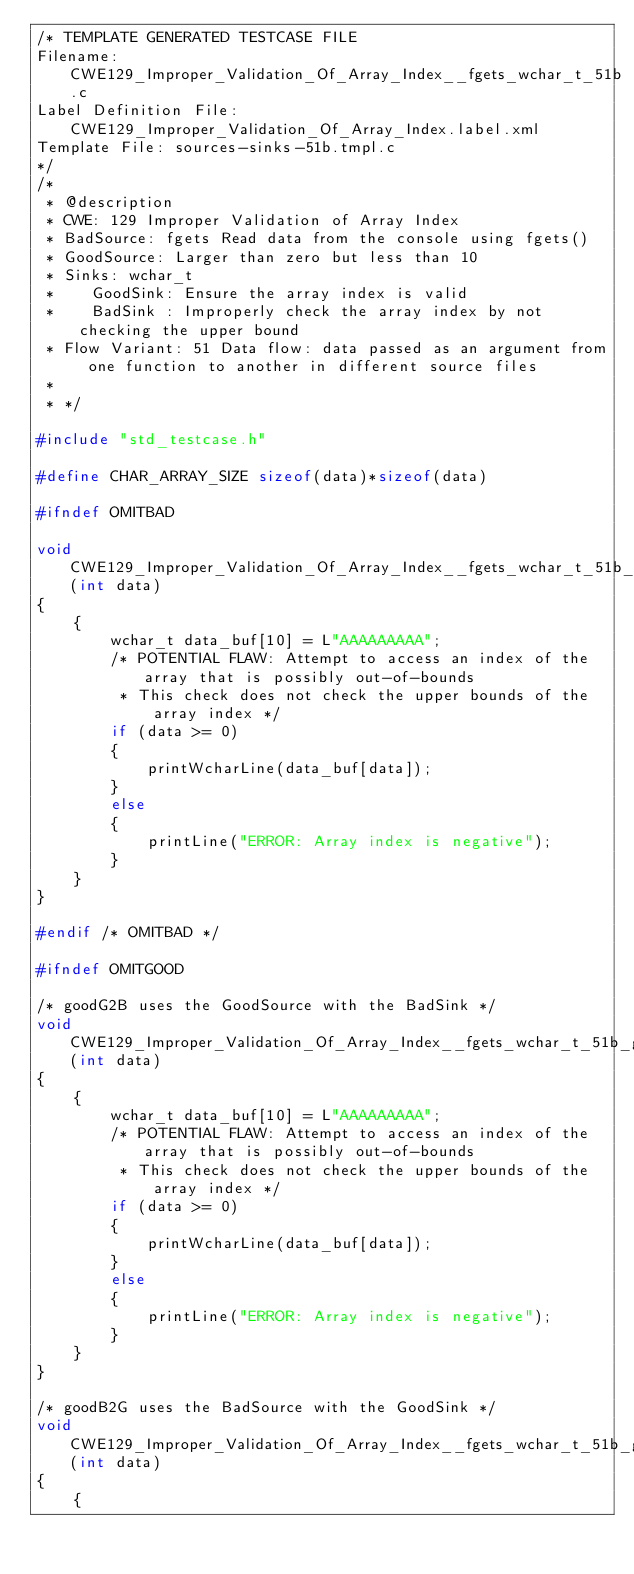Convert code to text. <code><loc_0><loc_0><loc_500><loc_500><_C_>/* TEMPLATE GENERATED TESTCASE FILE
Filename: CWE129_Improper_Validation_Of_Array_Index__fgets_wchar_t_51b.c
Label Definition File: CWE129_Improper_Validation_Of_Array_Index.label.xml
Template File: sources-sinks-51b.tmpl.c
*/
/*
 * @description
 * CWE: 129 Improper Validation of Array Index
 * BadSource: fgets Read data from the console using fgets()
 * GoodSource: Larger than zero but less than 10
 * Sinks: wchar_t
 *    GoodSink: Ensure the array index is valid
 *    BadSink : Improperly check the array index by not checking the upper bound
 * Flow Variant: 51 Data flow: data passed as an argument from one function to another in different source files
 *
 * */

#include "std_testcase.h"

#define CHAR_ARRAY_SIZE sizeof(data)*sizeof(data)

#ifndef OMITBAD

void CWE129_Improper_Validation_Of_Array_Index__fgets_wchar_t_51b_bad_sink(int data)
{
    {
        wchar_t data_buf[10] = L"AAAAAAAAA";
        /* POTENTIAL FLAW: Attempt to access an index of the array that is possibly out-of-bounds
         * This check does not check the upper bounds of the array index */
        if (data >= 0)
        {
            printWcharLine(data_buf[data]);
        }
        else
        {
            printLine("ERROR: Array index is negative");
        }
    }
}

#endif /* OMITBAD */

#ifndef OMITGOOD

/* goodG2B uses the GoodSource with the BadSink */
void CWE129_Improper_Validation_Of_Array_Index__fgets_wchar_t_51b_goodG2B_sink(int data)
{
    {
        wchar_t data_buf[10] = L"AAAAAAAAA";
        /* POTENTIAL FLAW: Attempt to access an index of the array that is possibly out-of-bounds
         * This check does not check the upper bounds of the array index */
        if (data >= 0)
        {
            printWcharLine(data_buf[data]);
        }
        else
        {
            printLine("ERROR: Array index is negative");
        }
    }
}

/* goodB2G uses the BadSource with the GoodSink */
void CWE129_Improper_Validation_Of_Array_Index__fgets_wchar_t_51b_goodB2G_sink(int data)
{
    {</code> 